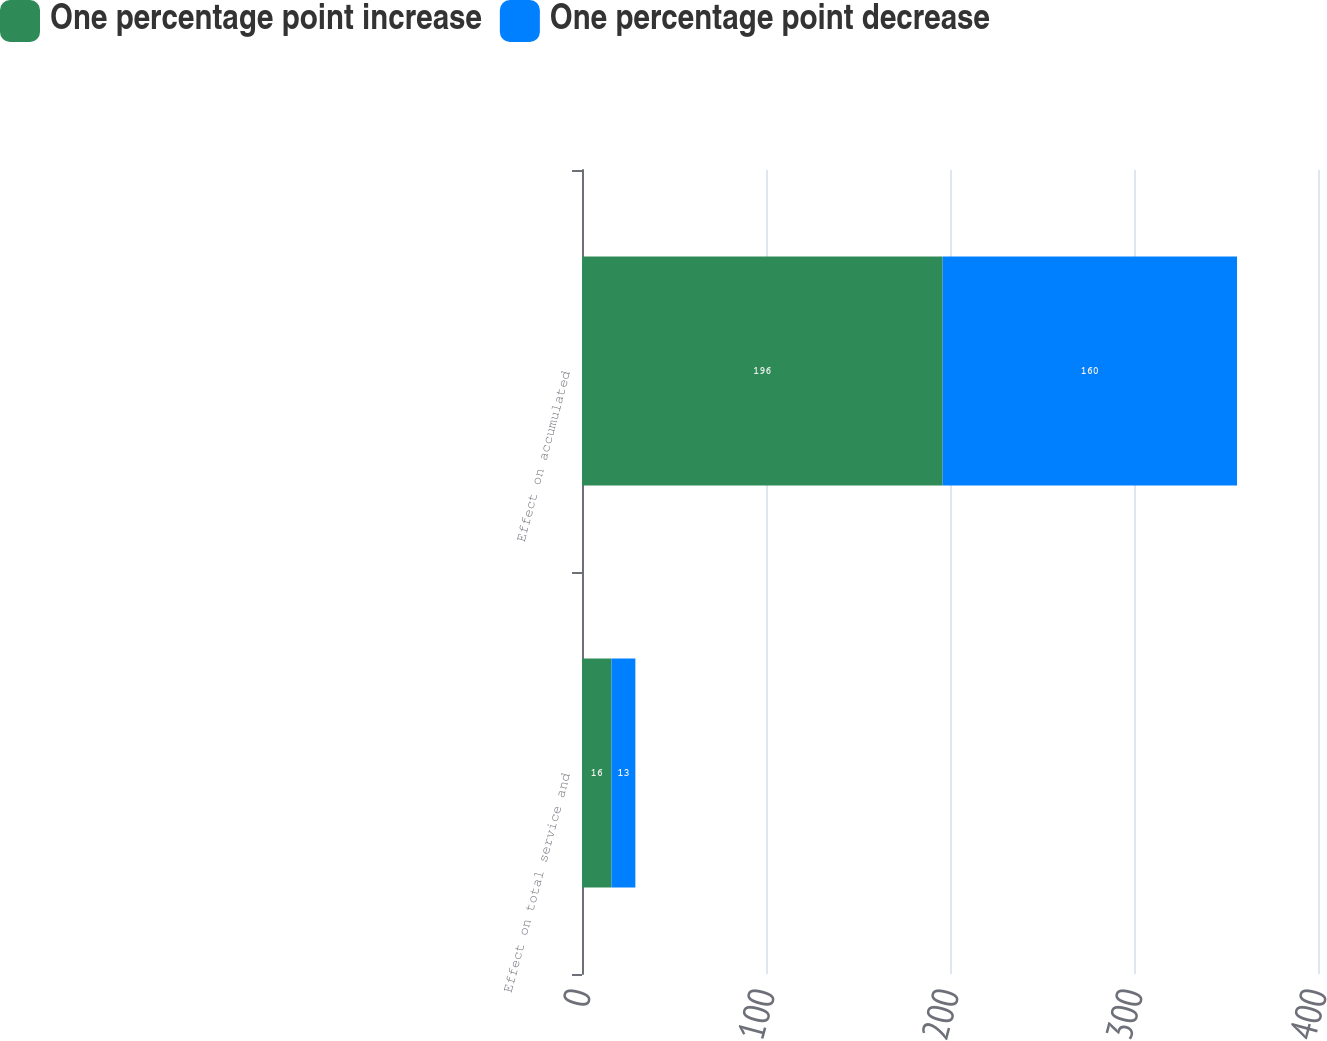<chart> <loc_0><loc_0><loc_500><loc_500><stacked_bar_chart><ecel><fcel>Effect on total service and<fcel>Effect on accumulated<nl><fcel>One percentage point increase<fcel>16<fcel>196<nl><fcel>One percentage point decrease<fcel>13<fcel>160<nl></chart> 